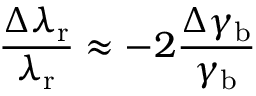Convert formula to latex. <formula><loc_0><loc_0><loc_500><loc_500>\frac { \Delta \lambda _ { r } } { \lambda _ { r } } \approx - 2 \frac { \Delta \gamma _ { b } } { \gamma _ { b } }</formula> 